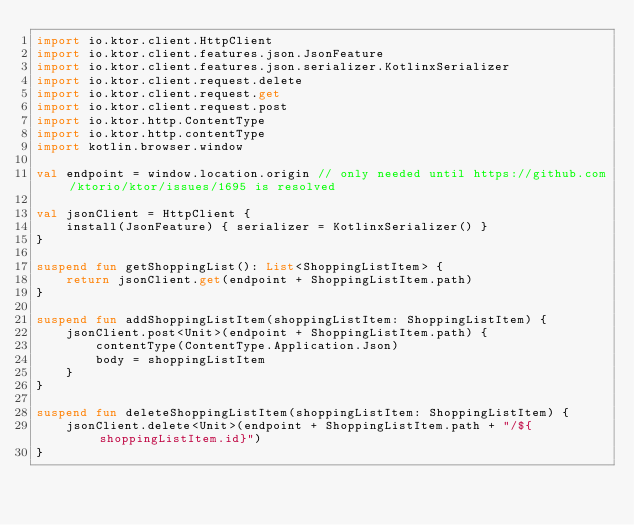Convert code to text. <code><loc_0><loc_0><loc_500><loc_500><_Kotlin_>import io.ktor.client.HttpClient
import io.ktor.client.features.json.JsonFeature
import io.ktor.client.features.json.serializer.KotlinxSerializer
import io.ktor.client.request.delete
import io.ktor.client.request.get
import io.ktor.client.request.post
import io.ktor.http.ContentType
import io.ktor.http.contentType
import kotlin.browser.window

val endpoint = window.location.origin // only needed until https://github.com/ktorio/ktor/issues/1695 is resolved

val jsonClient = HttpClient {
    install(JsonFeature) { serializer = KotlinxSerializer() }
}

suspend fun getShoppingList(): List<ShoppingListItem> {
    return jsonClient.get(endpoint + ShoppingListItem.path)
}

suspend fun addShoppingListItem(shoppingListItem: ShoppingListItem) {
    jsonClient.post<Unit>(endpoint + ShoppingListItem.path) {
        contentType(ContentType.Application.Json)
        body = shoppingListItem
    }
}

suspend fun deleteShoppingListItem(shoppingListItem: ShoppingListItem) {
    jsonClient.delete<Unit>(endpoint + ShoppingListItem.path + "/${shoppingListItem.id}")
}</code> 